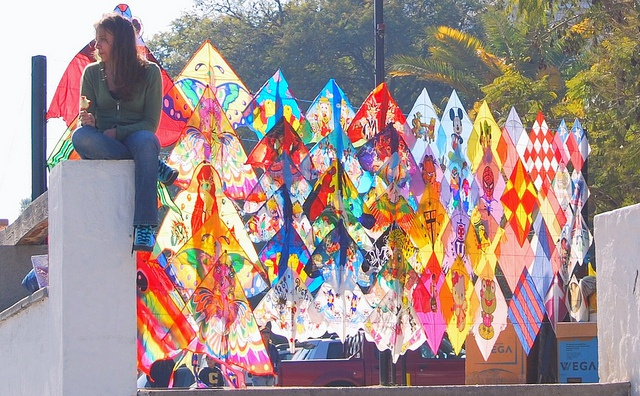Describe the objects in this image and their specific colors. I can see kite in white, lightpink, khaki, and salmon tones, people in white, gray, darkblue, and black tones, kite in white, salmon, lightpink, and tan tones, truck in white, purple, black, and lavender tones, and kite in white, khaki, lightpink, and tan tones in this image. 